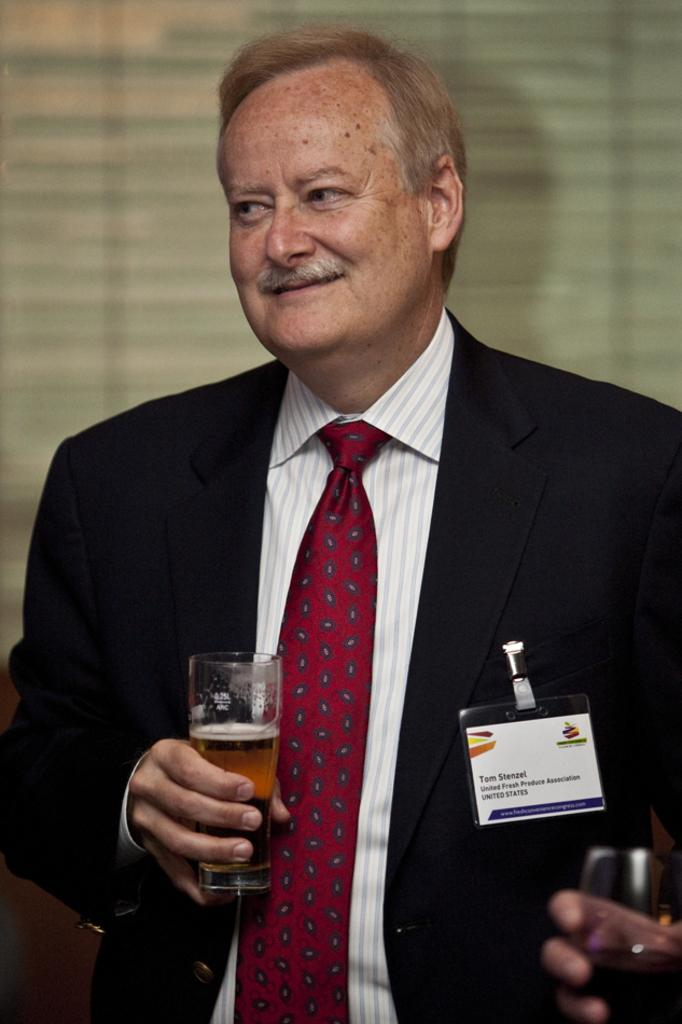Who is present in the image? There is a man in the image. What is the man wearing? The man is wearing a blazer and a tie. What is the man holding in his hand? The man is holding a glass in his hand. What is inside the glass? There is a drink in the glass. What is the man's facial expression? The man is smiling. What type of dog is sitting on the chair next to the man in the image? There is no dog present in the image. Is the man sitting on a boat in the image? There is no boat present in the image. 